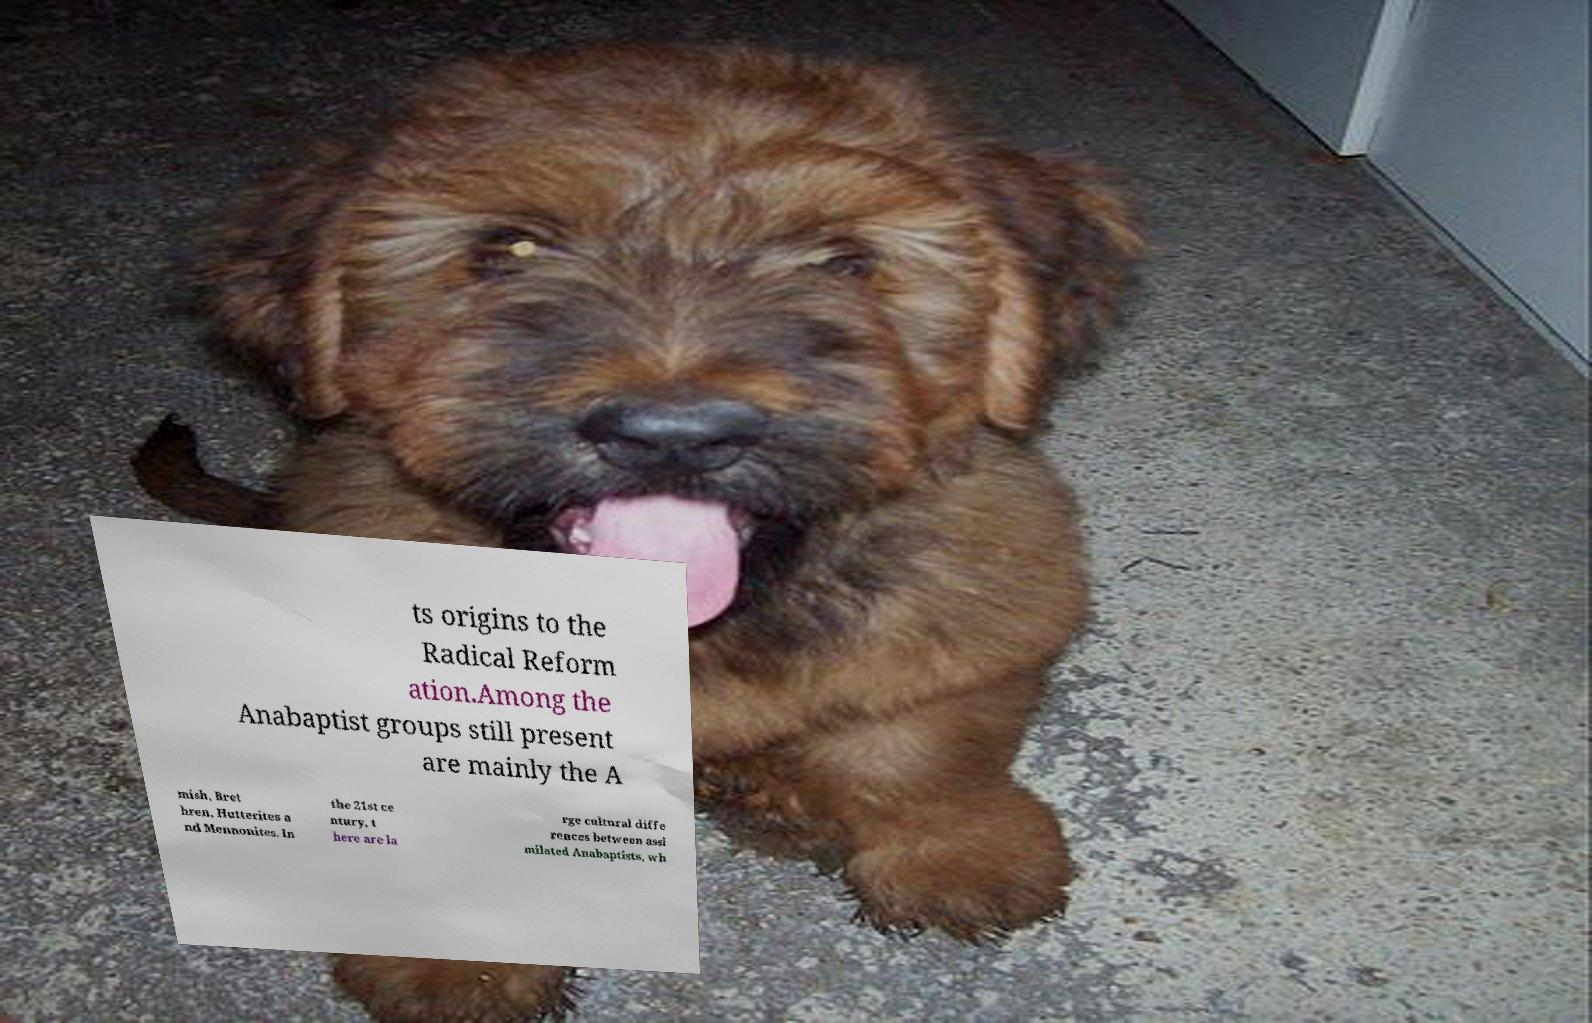Can you accurately transcribe the text from the provided image for me? ts origins to the Radical Reform ation.Among the Anabaptist groups still present are mainly the A mish, Bret hren, Hutterites a nd Mennonites. In the 21st ce ntury, t here are la rge cultural diffe rences between assi milated Anabaptists, wh 